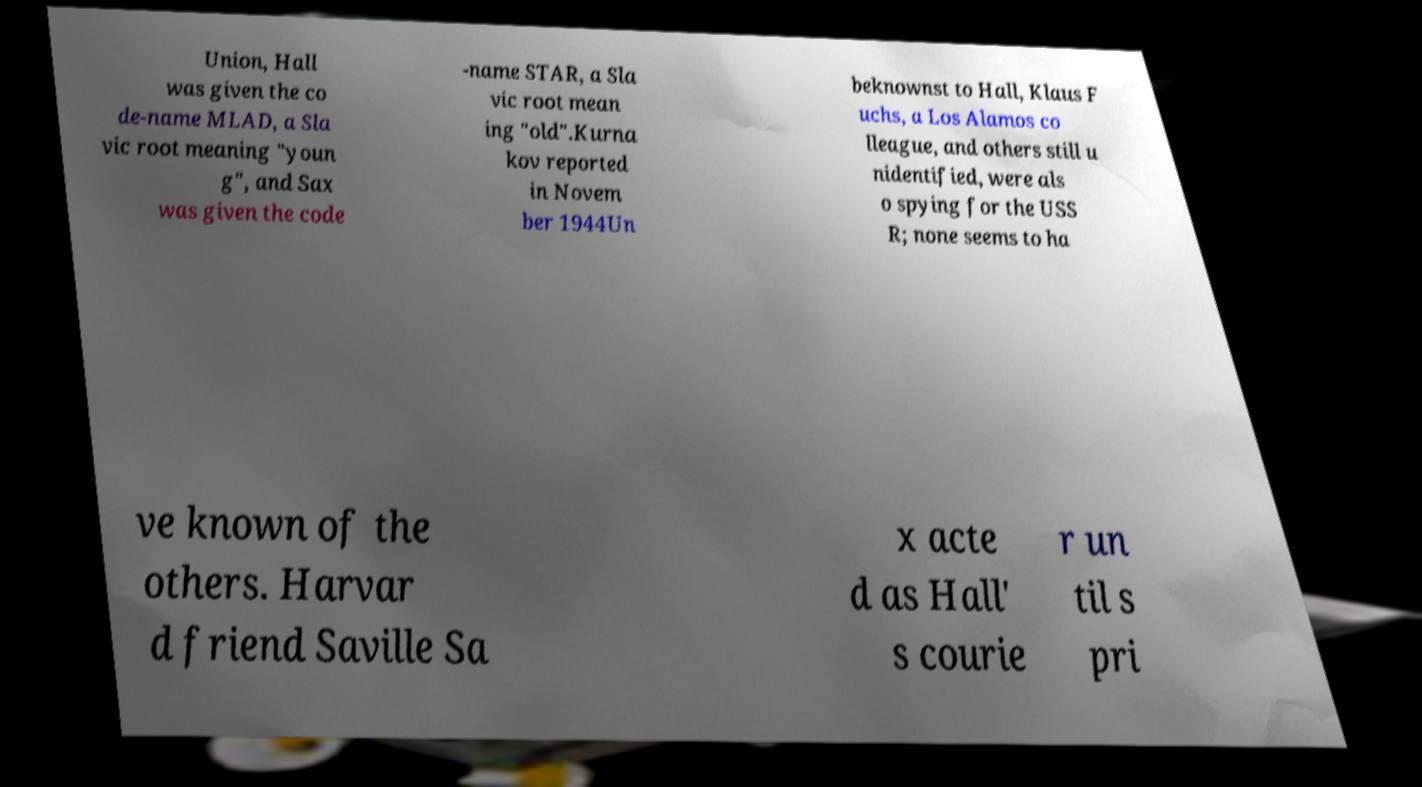Can you accurately transcribe the text from the provided image for me? Union, Hall was given the co de-name MLAD, a Sla vic root meaning "youn g", and Sax was given the code -name STAR, a Sla vic root mean ing "old".Kurna kov reported in Novem ber 1944Un beknownst to Hall, Klaus F uchs, a Los Alamos co lleague, and others still u nidentified, were als o spying for the USS R; none seems to ha ve known of the others. Harvar d friend Saville Sa x acte d as Hall' s courie r un til s pri 